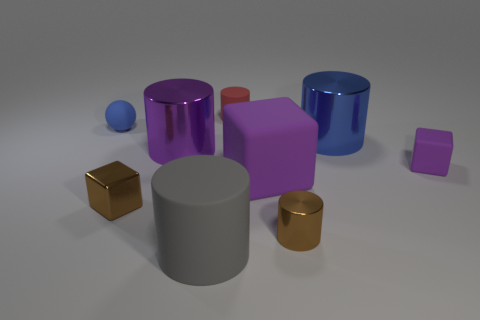What shape is the small thing that is the same color as the big rubber cube?
Offer a very short reply. Cube. Does the blue thing that is behind the big blue metallic object have the same size as the purple cube right of the big blue object?
Give a very brief answer. Yes. There is a small thing that is both right of the small red cylinder and left of the small purple rubber block; what is its material?
Offer a terse response. Metal. Is there anything else of the same color as the big block?
Make the answer very short. Yes. Is the number of tiny brown objects behind the red object less than the number of yellow spheres?
Offer a very short reply. No. Is the number of gray matte objects greater than the number of objects?
Your response must be concise. No. There is a cube on the left side of the purple cube on the left side of the big blue object; are there any small brown objects that are on the left side of it?
Your answer should be compact. No. What number of other objects are the same size as the blue cylinder?
Offer a terse response. 3. There is a small red cylinder; are there any small brown cylinders to the left of it?
Keep it short and to the point. No. Do the small rubber sphere and the cylinder that is behind the blue sphere have the same color?
Keep it short and to the point. No. 